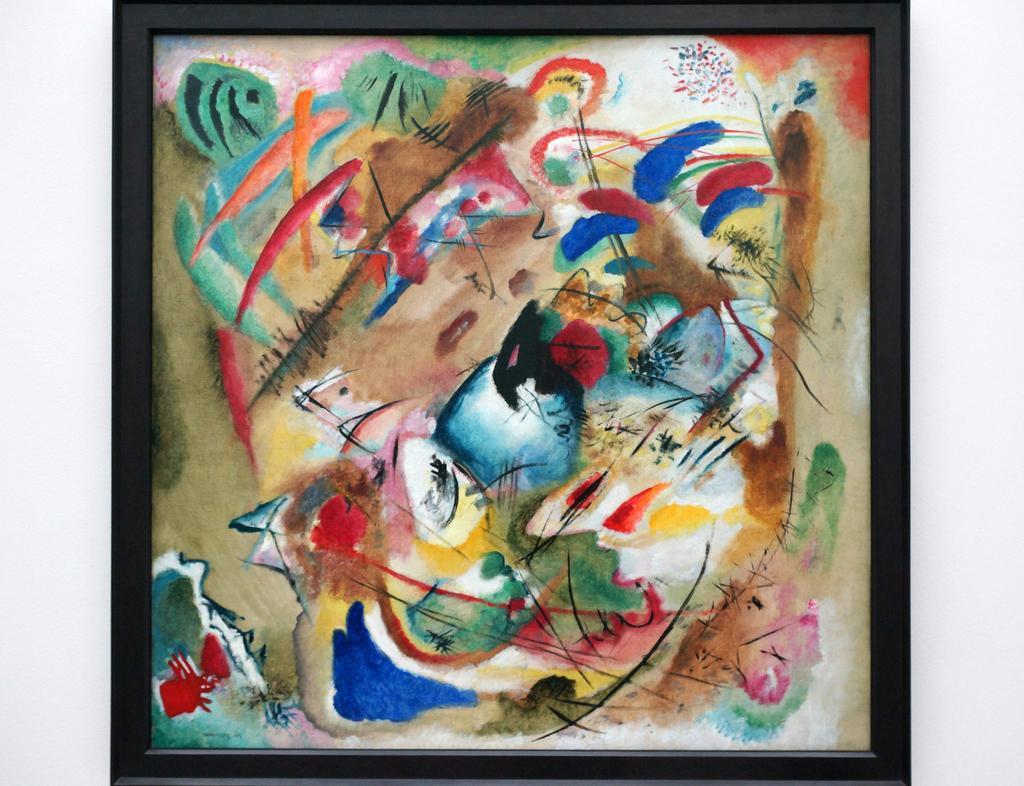How would you summarize this image in a sentence or two? In this image we can see an abstract painting on a photo frame. 